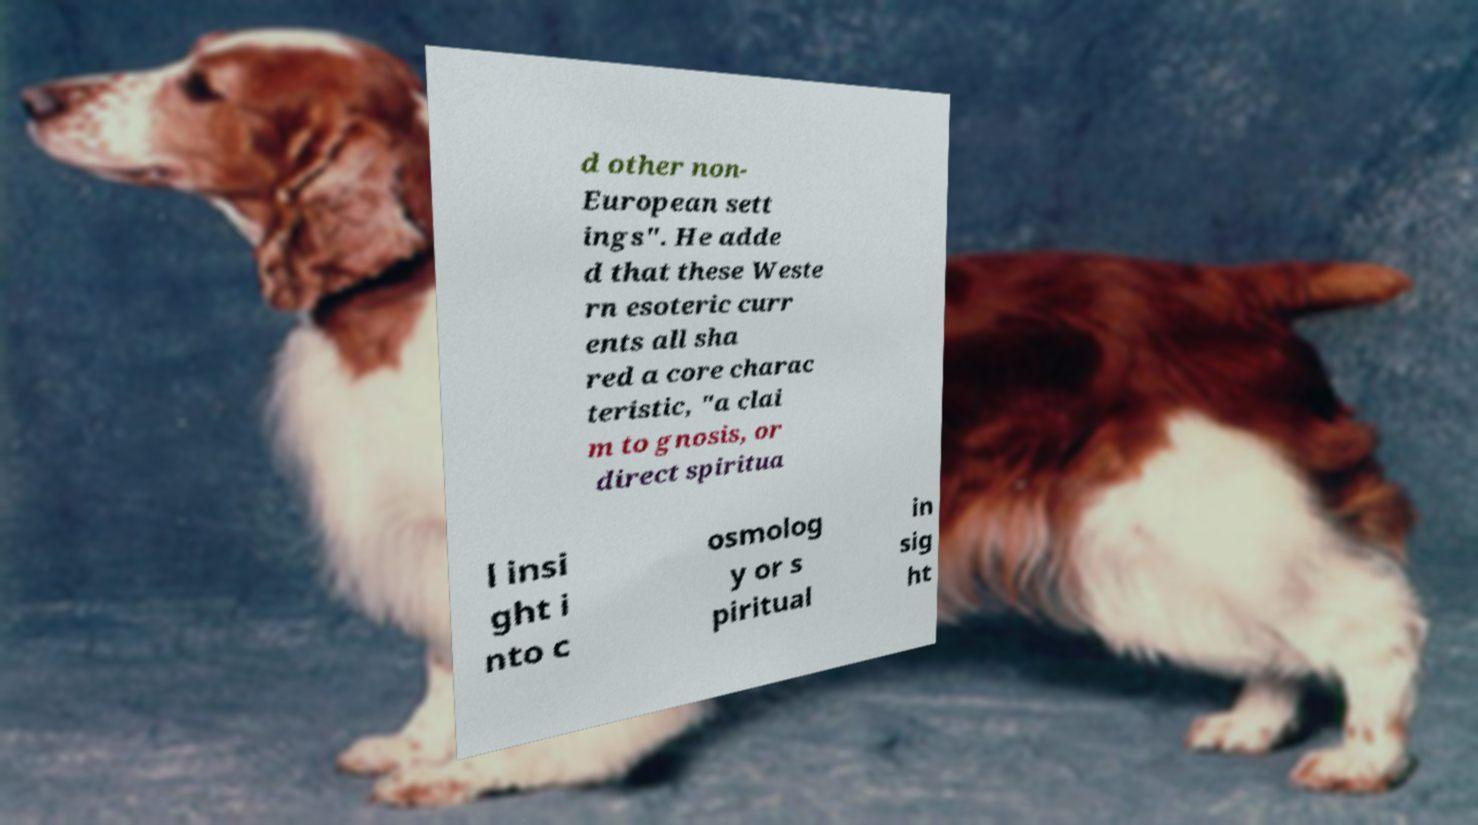Can you read and provide the text displayed in the image?This photo seems to have some interesting text. Can you extract and type it out for me? d other non- European sett ings". He adde d that these Weste rn esoteric curr ents all sha red a core charac teristic, "a clai m to gnosis, or direct spiritua l insi ght i nto c osmolog y or s piritual in sig ht 